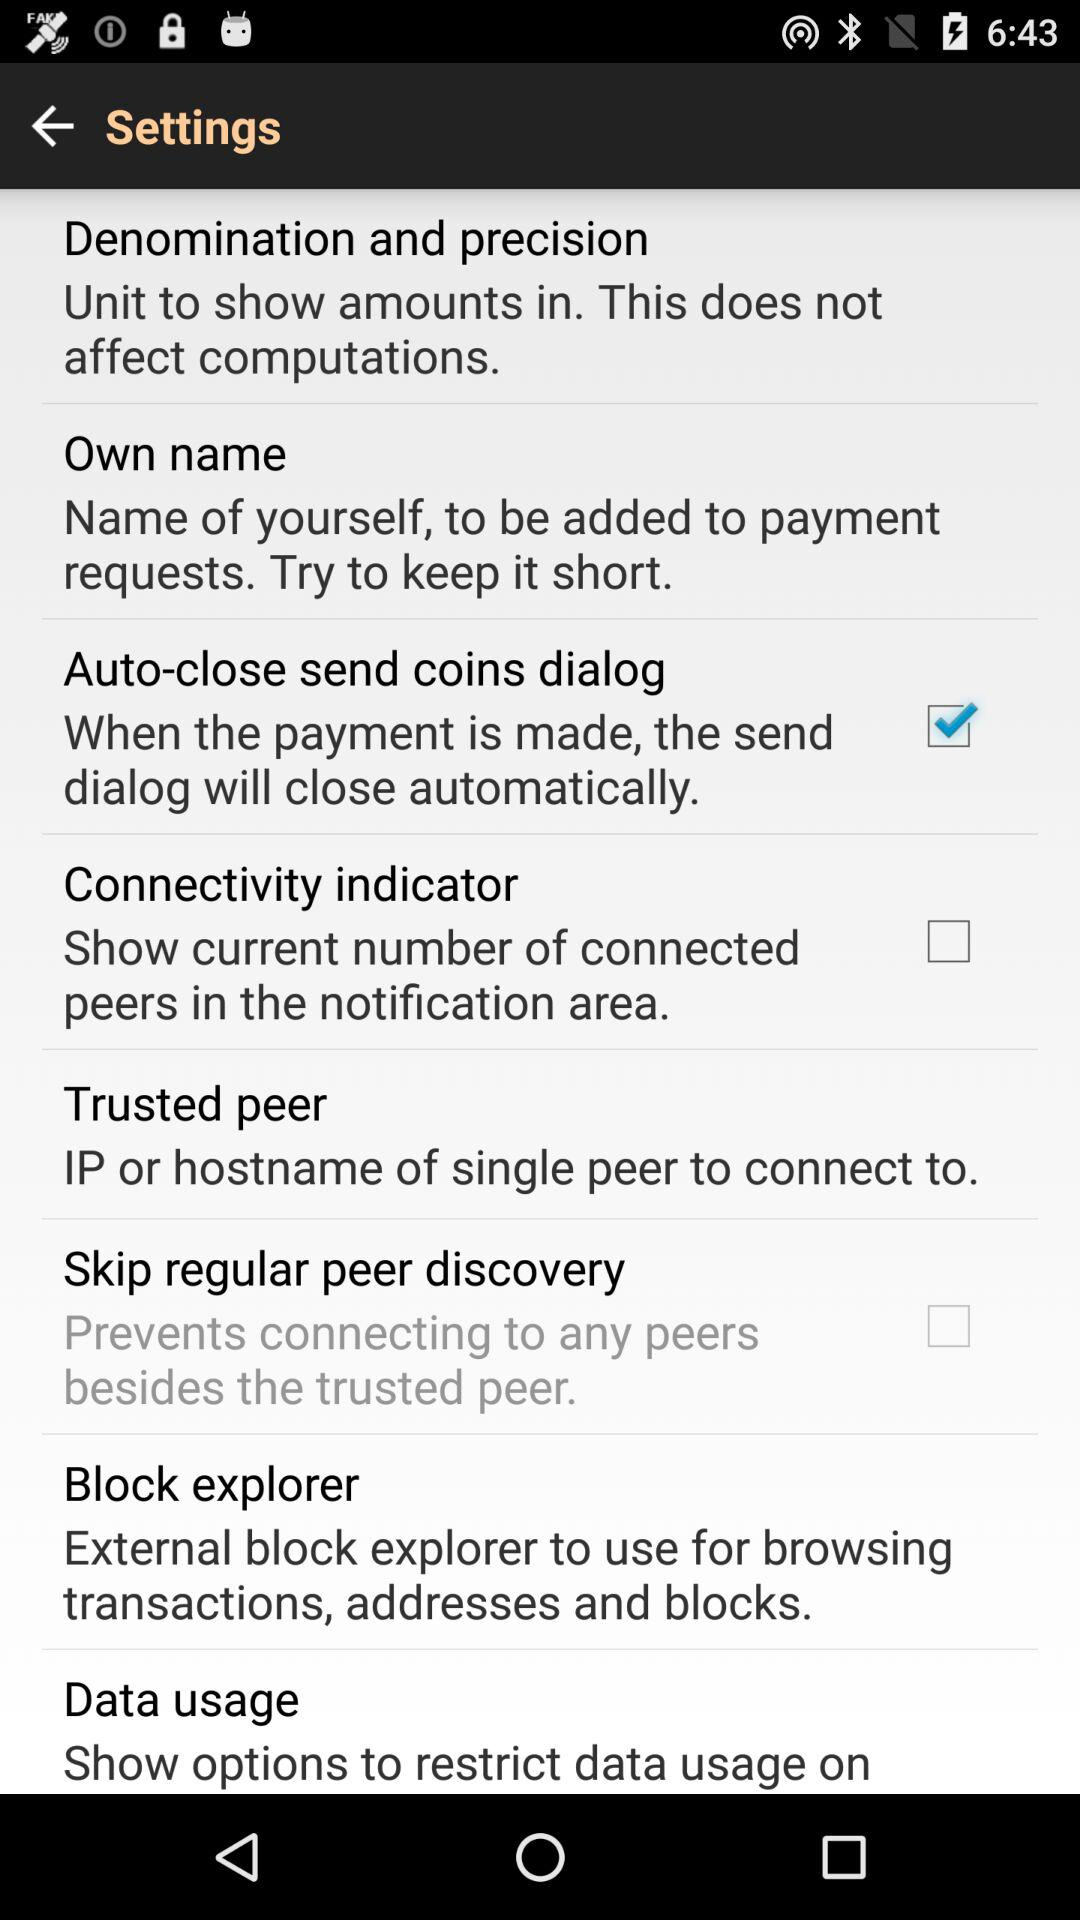Which option is not marked as checked? The options that are not marked as checked are "Connectivity indicator" and "Skip regular peer discovery". 